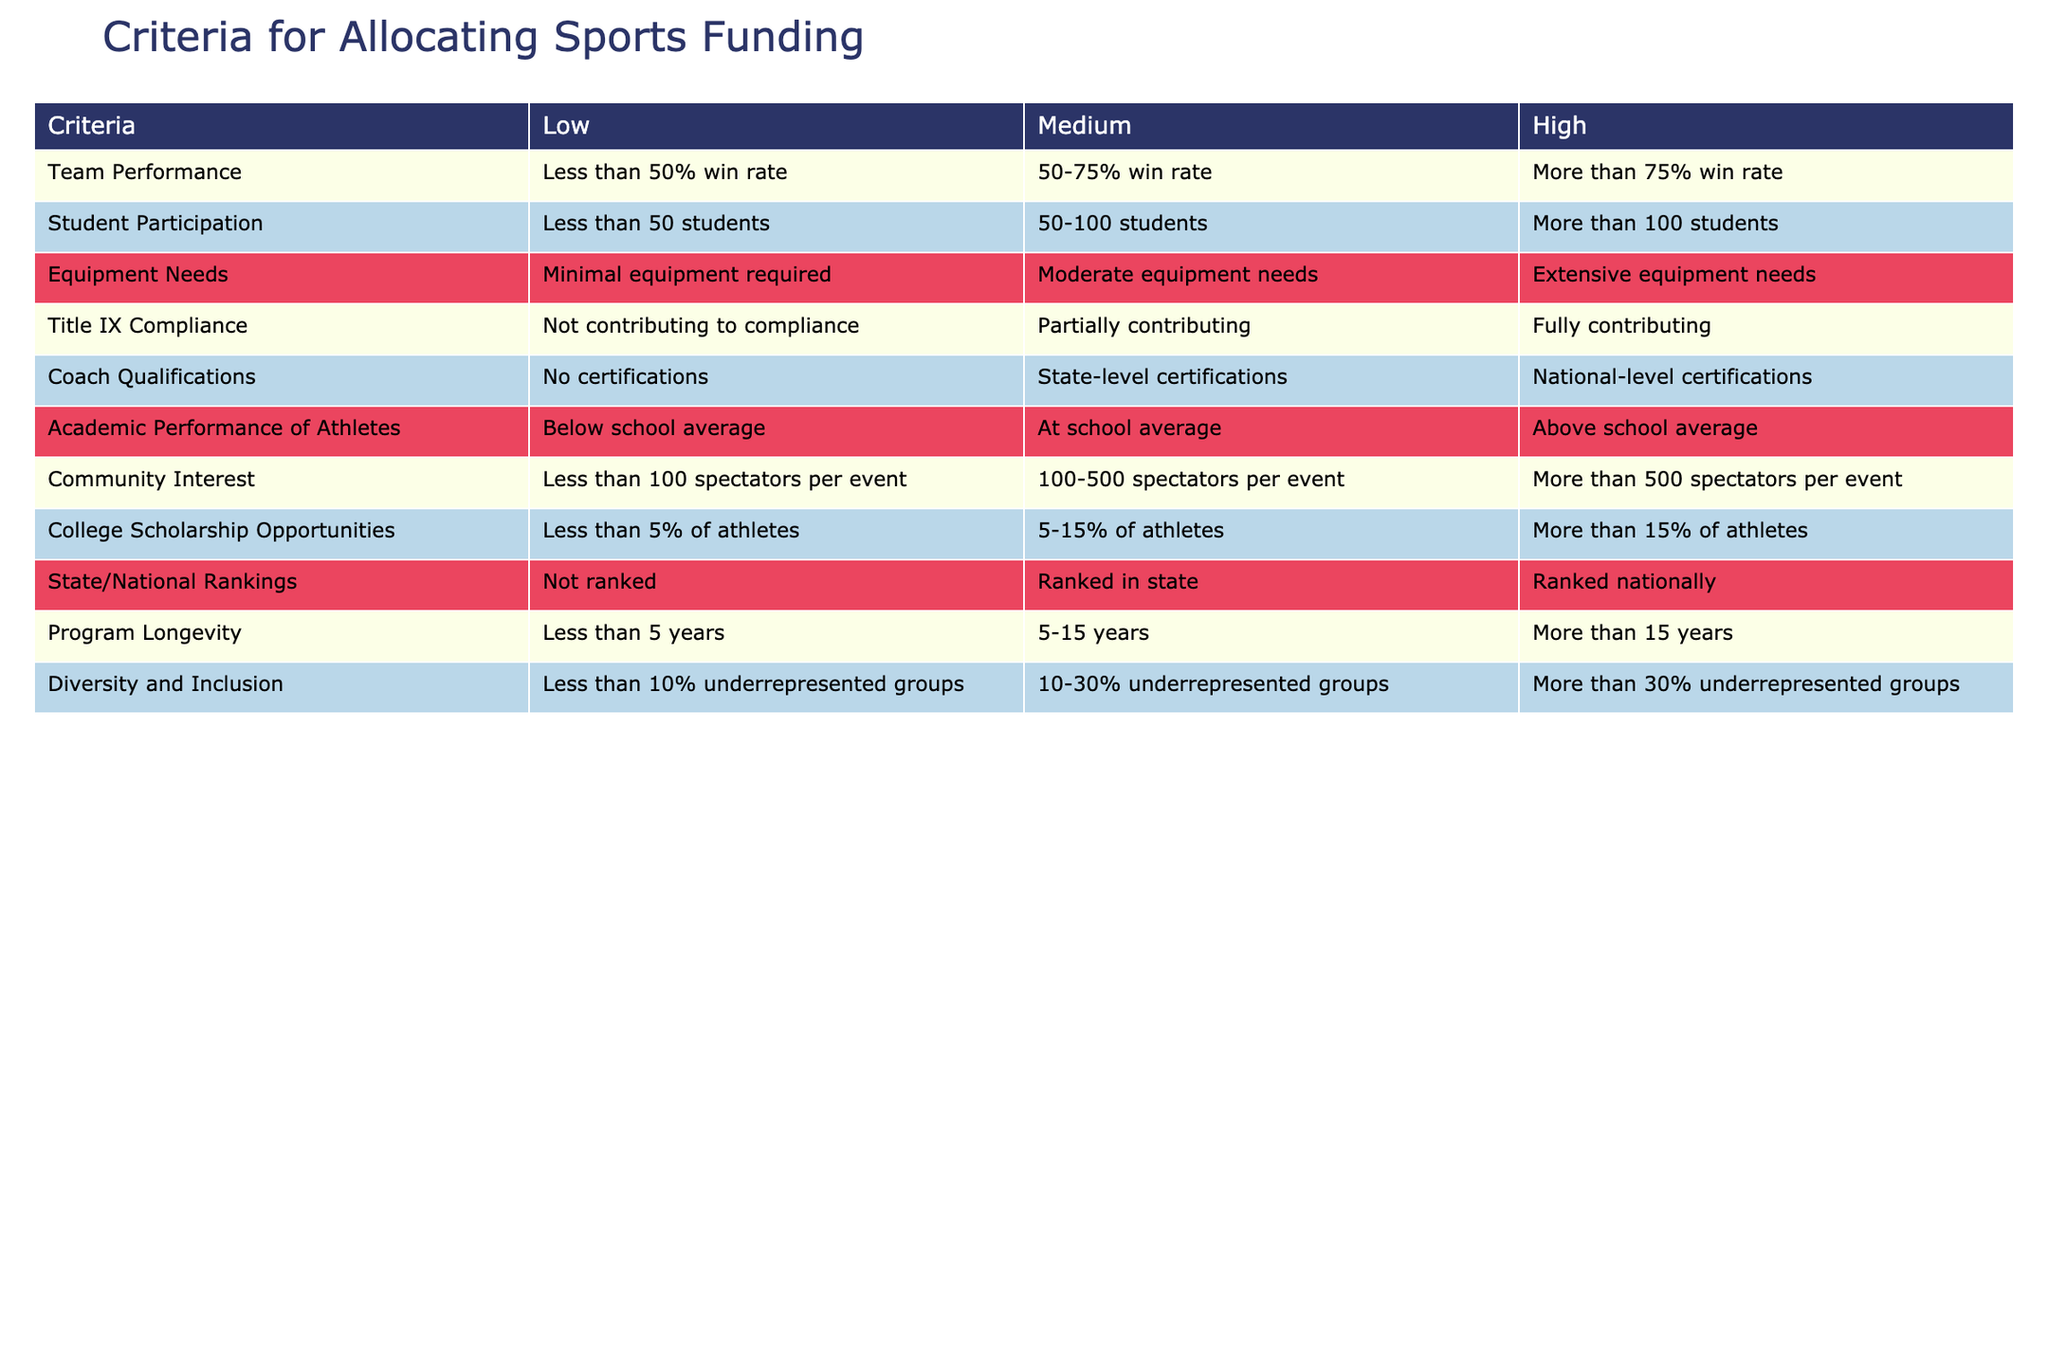What are the criteria for allocating sports funding? The table presents a comprehensive list of criteria, including Team Performance, Student Participation, Equipment Needs, Title IX Compliance, Coach Qualifications, Academic Performance of Athletes, Community Interest, College Scholarship Opportunities, State/National Rankings, Program Longevity, and Diversity and Inclusion.
Answer: Team Performance, Student Participation, Equipment Needs, Title IX Compliance, Coach Qualifications, Academic Performance of Athletes, Community Interest, College Scholarship Opportunities, State/National Rankings, Program Longevity, Diversity and Inclusion Which category represents a high level of College Scholarship Opportunities? According to the table, the high category for College Scholarship Opportunities is defined as having more than 15% of athletes receiving scholarships.
Answer: More than 15% of athletes How many students are considered in the Medium range for Student Participation? The Medium range for Student Participation is from 50 to 100 students, as per the table.
Answer: 50-100 students Is it true that a program can qualify for high funding even with minimal equipment needs? According to this table, the criteria for Equipment Needs states that a program requires extensive equipment needs to qualify for high funding. Therefore, it is false that a program with minimal equipment can qualify for high funding.
Answer: False What is the state ranking category threshold for a program to be considered highly ranked? The table indicates that a program is considered highly ranked if it is ranked nationally. Thus, the criteria for a program to receive a higher allocation of funding revolves around being ranked nationally.
Answer: Ranked nationally If a program has a win rate of 60% and has 120 participating students, how does it rank in the table? For Team Performance, a win rate of 60% falls in the Medium category (50-75% win rate), and for Student Participation, 120 students exceeds the high category (more than 100 students). Therefore, the program ranks Medium for Team Performance and High for Student Participation.
Answer: Medium for Team Performance, High for Student Participation Are there more criteria for funding allocation that focus on compliance and legal issues, or performance metrics? Examining the table, there are two criteria related to compliance (Title IX Compliance and Diversity and Inclusion) and six related to performance metrics (Team Performance, Student Participation, Equipment Needs, Coach Qualifications, Academic Performance of Athletes, and College Scholarship Opportunities). This indicates that there are more criteria focused on performance metrics than on compliance.
Answer: More focus on performance metrics What is the relationship between Program Longevity and funding allocation, based on the table? The table shows that a longer Program Longevity (more than 15 years) is associated with higher funding allocations, while programs with less than 5 years have a lower allocation. This implies that programs that last longer tend to receive more funding.
Answer: Longer programs receive more funding Which criteria includes both performance and compliance aspects according to the table? Looking closely, the criteria for Diversity and Inclusion can be seen as encompassing both performance (inclusion criteria) and compliance (aligning with Title IX regulations). This dual aspect reflects its importance in funding allocation.
Answer: Diversity and Inclusion 